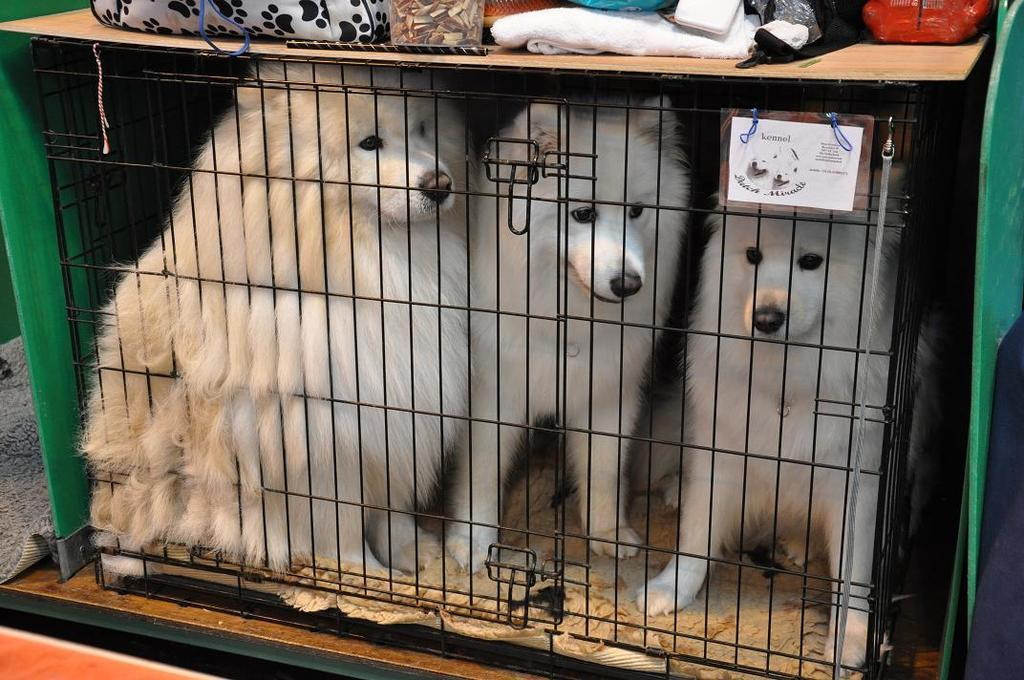How many dogs are present in the image? There are three dogs in the image. Where are the dogs located? The dogs are inside a dog crate. What can be seen on the dog crate? There are items on a wooden board on the dog crate. What type of mine is visible in the image? There is no mine present in the image; it features three dogs inside a dog crate with items on a wooden board. 